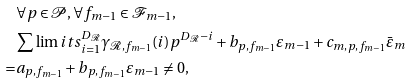Convert formula to latex. <formula><loc_0><loc_0><loc_500><loc_500>& \forall p \in \mathcal { P } , \forall f _ { m - 1 } \in \mathcal { F } _ { m - 1 } , \\ & \sum \lim i t s _ { i = 1 } ^ { D _ { \mathcal { R } } } \gamma _ { \mathcal { R } , f _ { m - 1 } } ( i ) p ^ { D _ { \mathcal { R } } - i } + b _ { p , f _ { m - 1 } } \varepsilon _ { m - 1 } + c _ { m , p , f _ { m - 1 } } \bar { \varepsilon } _ { m } \\ = & a _ { p , f _ { m - 1 } } + b _ { p , f _ { m - 1 } } \varepsilon _ { m - 1 } \neq 0 ,</formula> 